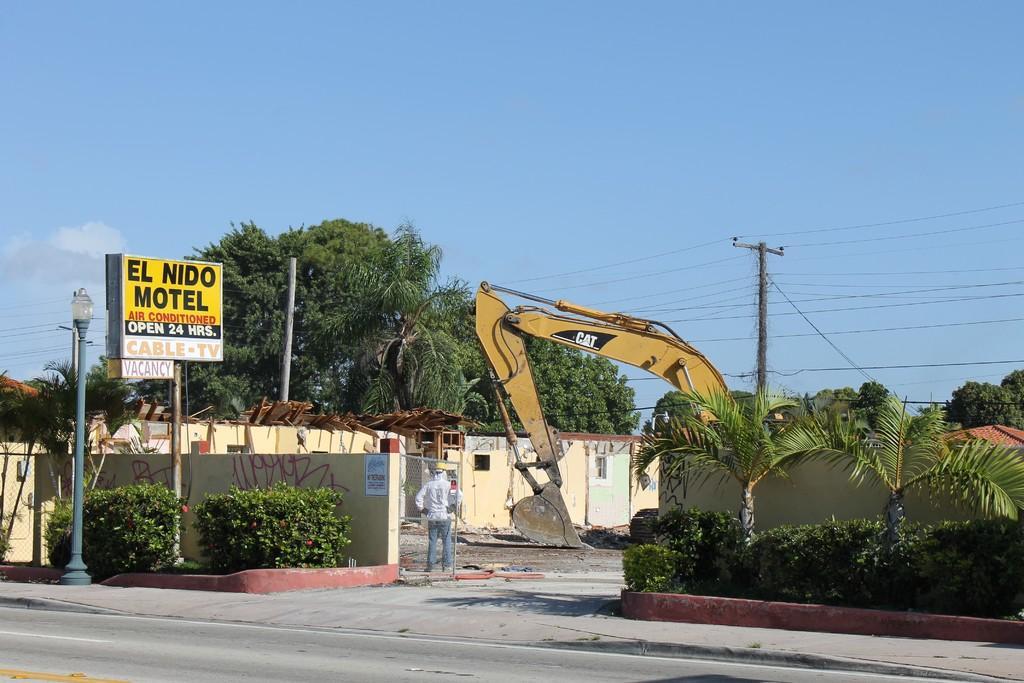Could you give a brief overview of what you see in this image? In this image we can see an excavator, buildings, electric poles, electric cables, trees, bushes, street pole, street lights, information board and sky in the background. 